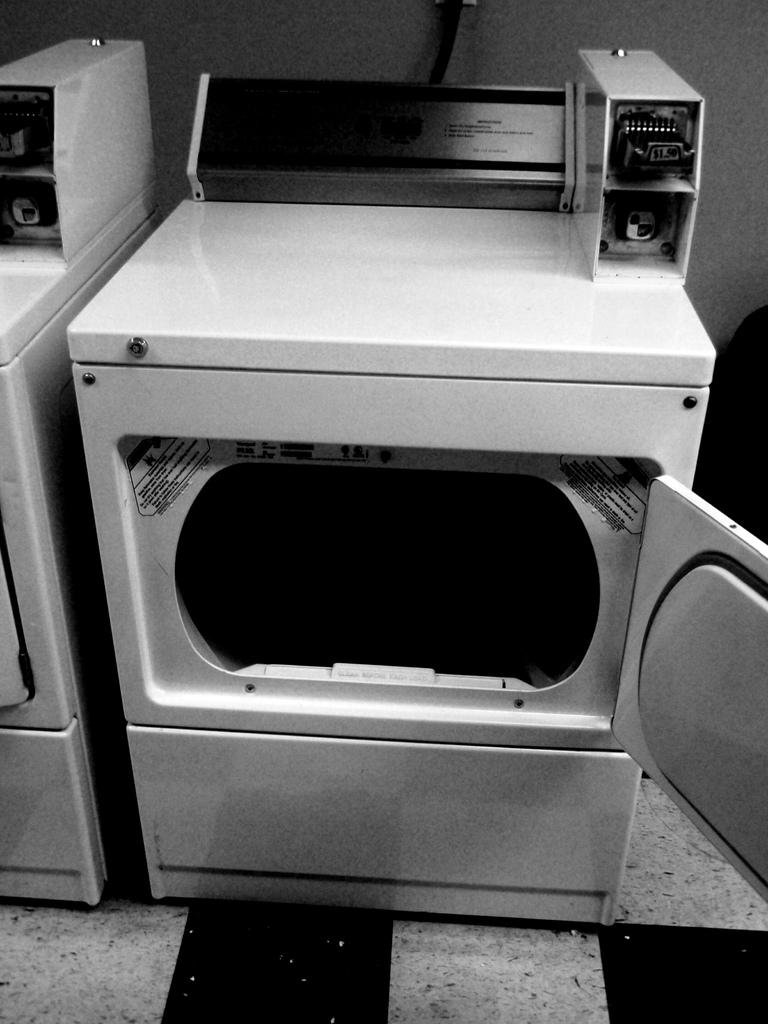What appliances are in the image? There are two white washing machines in the image. Where are the washing machines located? The washing machines are in the middle of the image. What can be seen at the bottom of the image? There is a floor visible at the bottom of the image. What is visible at the top of the image? There is a wall visible at the top of the image. What type of grape is being used to clean the washing machines in the image? There is no grape present in the image, and grapes are not used for cleaning washing machines. 